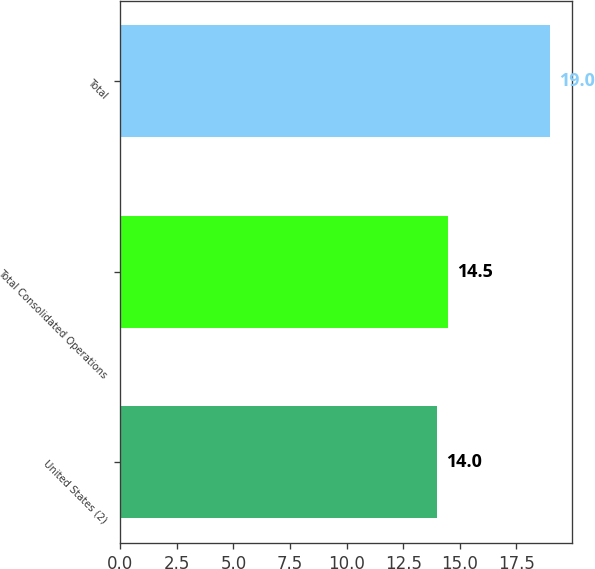Convert chart. <chart><loc_0><loc_0><loc_500><loc_500><bar_chart><fcel>United States (2)<fcel>Total Consolidated Operations<fcel>Total<nl><fcel>14<fcel>14.5<fcel>19<nl></chart> 